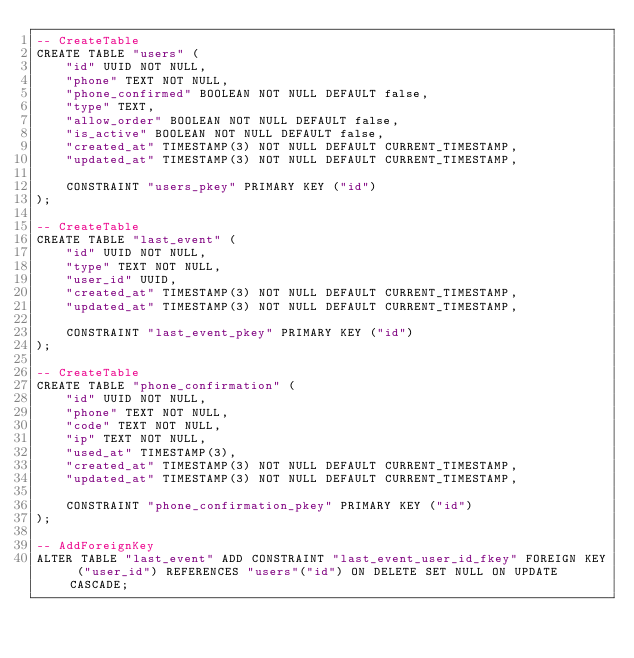Convert code to text. <code><loc_0><loc_0><loc_500><loc_500><_SQL_>-- CreateTable
CREATE TABLE "users" (
    "id" UUID NOT NULL,
    "phone" TEXT NOT NULL,
    "phone_confirmed" BOOLEAN NOT NULL DEFAULT false,
    "type" TEXT,
    "allow_order" BOOLEAN NOT NULL DEFAULT false,
    "is_active" BOOLEAN NOT NULL DEFAULT false,
    "created_at" TIMESTAMP(3) NOT NULL DEFAULT CURRENT_TIMESTAMP,
    "updated_at" TIMESTAMP(3) NOT NULL DEFAULT CURRENT_TIMESTAMP,

    CONSTRAINT "users_pkey" PRIMARY KEY ("id")
);

-- CreateTable
CREATE TABLE "last_event" (
    "id" UUID NOT NULL,
    "type" TEXT NOT NULL,
    "user_id" UUID,
    "created_at" TIMESTAMP(3) NOT NULL DEFAULT CURRENT_TIMESTAMP,
    "updated_at" TIMESTAMP(3) NOT NULL DEFAULT CURRENT_TIMESTAMP,

    CONSTRAINT "last_event_pkey" PRIMARY KEY ("id")
);

-- CreateTable
CREATE TABLE "phone_confirmation" (
    "id" UUID NOT NULL,
    "phone" TEXT NOT NULL,
    "code" TEXT NOT NULL,
    "ip" TEXT NOT NULL,
    "used_at" TIMESTAMP(3),
    "created_at" TIMESTAMP(3) NOT NULL DEFAULT CURRENT_TIMESTAMP,
    "updated_at" TIMESTAMP(3) NOT NULL DEFAULT CURRENT_TIMESTAMP,

    CONSTRAINT "phone_confirmation_pkey" PRIMARY KEY ("id")
);

-- AddForeignKey
ALTER TABLE "last_event" ADD CONSTRAINT "last_event_user_id_fkey" FOREIGN KEY ("user_id") REFERENCES "users"("id") ON DELETE SET NULL ON UPDATE CASCADE;
</code> 